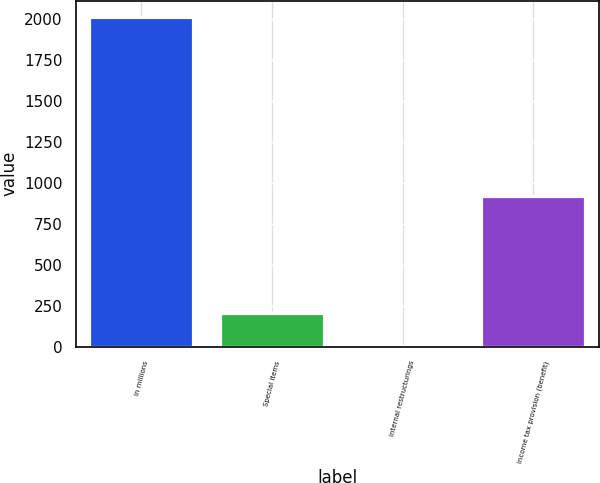<chart> <loc_0><loc_0><loc_500><loc_500><bar_chart><fcel>In millions<fcel>Special items<fcel>Internal restructurings<fcel>Income tax provision (benefit)<nl><fcel>2013<fcel>204.9<fcel>4<fcel>924<nl></chart> 